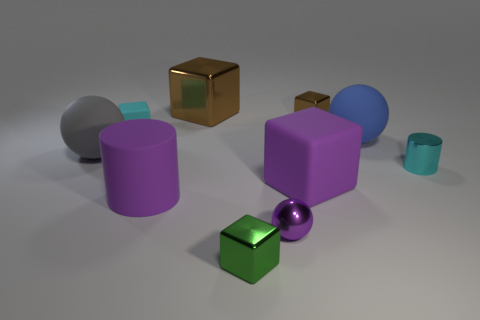Subtract all cyan blocks. How many blocks are left? 4 Subtract 1 blocks. How many blocks are left? 4 Subtract all cyan cubes. How many cubes are left? 4 Subtract all gray blocks. Subtract all green spheres. How many blocks are left? 5 Subtract all spheres. How many objects are left? 7 Add 8 tiny purple metallic spheres. How many tiny purple metallic spheres are left? 9 Add 10 big blue metal blocks. How many big blue metal blocks exist? 10 Subtract 1 cyan cubes. How many objects are left? 9 Subtract all rubber objects. Subtract all tiny green cubes. How many objects are left? 4 